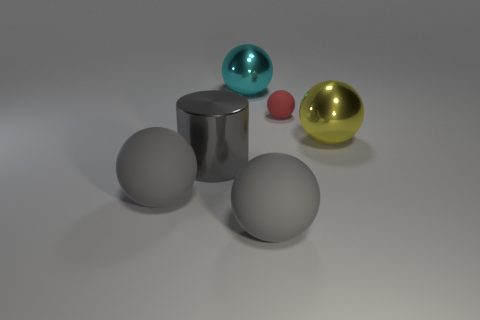Subtract 2 spheres. How many spheres are left? 3 Subtract all large yellow shiny balls. How many balls are left? 4 Subtract all yellow spheres. How many spheres are left? 4 Subtract all green spheres. Subtract all blue cylinders. How many spheres are left? 5 Add 2 tiny things. How many objects exist? 8 Subtract 0 red cylinders. How many objects are left? 6 Subtract all cylinders. How many objects are left? 5 Subtract all red metallic spheres. Subtract all big gray cylinders. How many objects are left? 5 Add 4 gray cylinders. How many gray cylinders are left? 5 Add 4 tiny objects. How many tiny objects exist? 5 